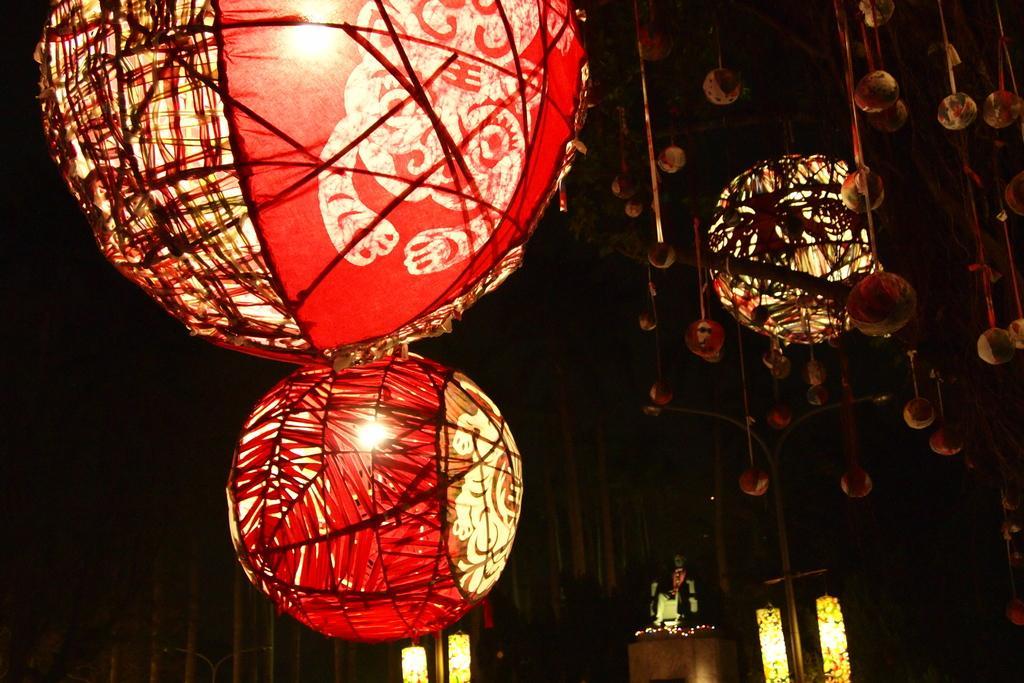Please provide a concise description of this image. In this picture we can see many paper lantern. At the bottom we can see the table, beside him we can see the lights. Behind him there is a wall. 